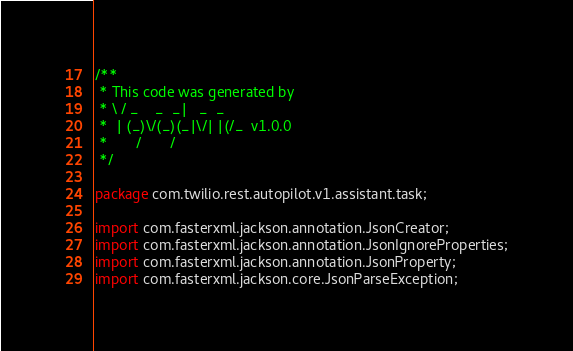Convert code to text. <code><loc_0><loc_0><loc_500><loc_500><_Java_>/**
 * This code was generated by
 * \ / _    _  _|   _  _
 *  | (_)\/(_)(_|\/| |(/_  v1.0.0
 *       /       /
 */

package com.twilio.rest.autopilot.v1.assistant.task;

import com.fasterxml.jackson.annotation.JsonCreator;
import com.fasterxml.jackson.annotation.JsonIgnoreProperties;
import com.fasterxml.jackson.annotation.JsonProperty;
import com.fasterxml.jackson.core.JsonParseException;</code> 